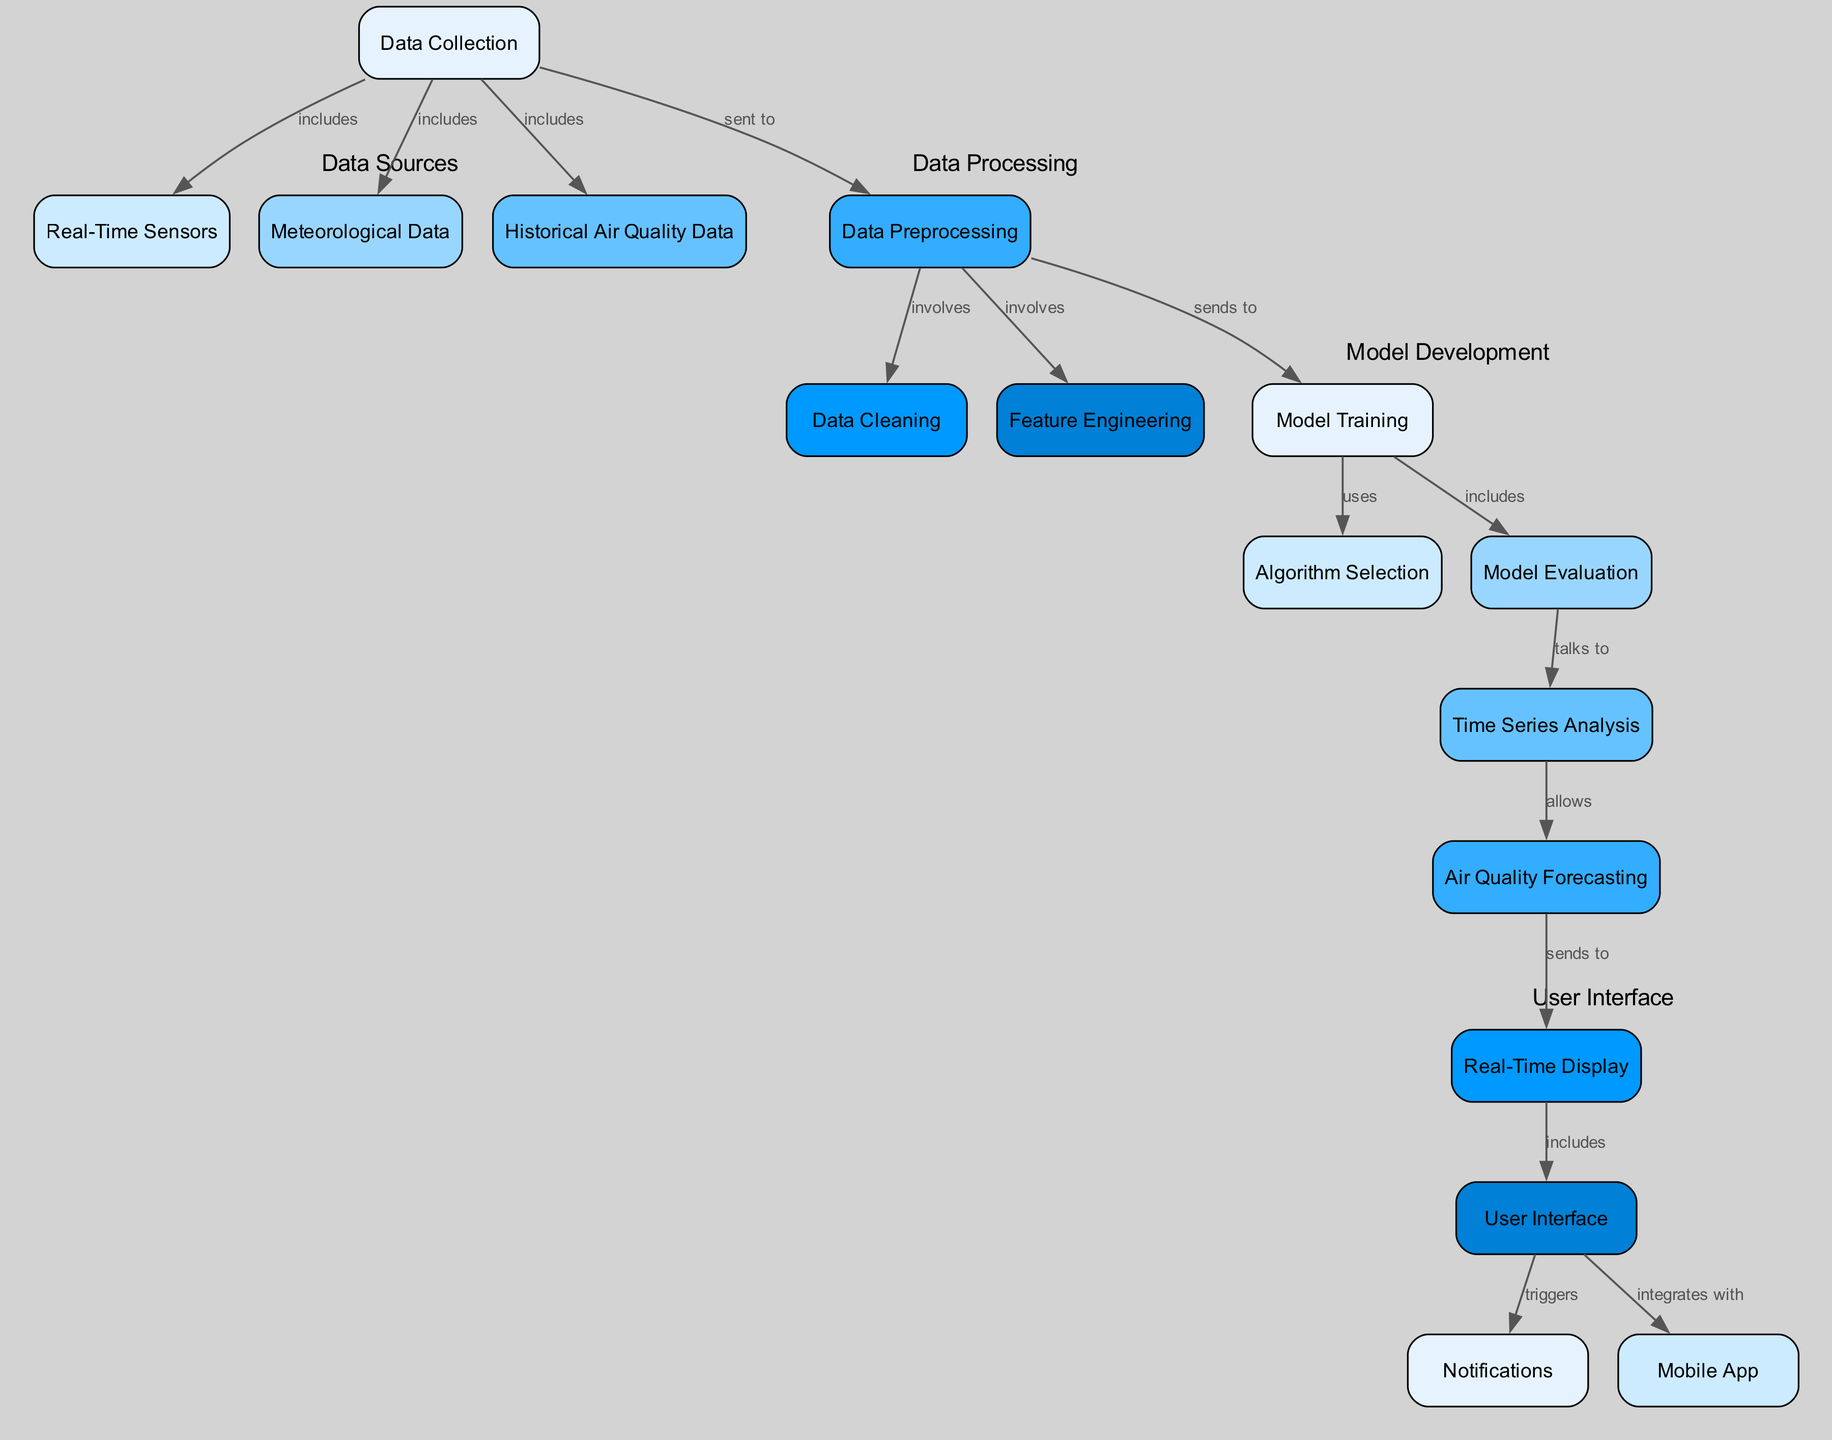What is the first step in the process? The first step in the process is represented by the node "Data Collection," which serves as the starting point for gathering various types of data.
Answer: Data Collection How many nodes are in the diagram? The diagram contains a total of 15 nodes, each representing different components of the air quality monitoring and forecasting system.
Answer: 15 What type of data is included in the Data Collection node? The Data Collection node includes three types of data: Real-Time Sensors, Meteorological Data, and Historical Air Quality Data.
Answer: Real-Time Sensors, Meteorological Data, Historical Air Quality Data What does the Time Series Analysis node allow? The Time Series Analysis node allows the forecasting of air quality based on processed data and established patterns over time, which is essential for predicting air quality levels.
Answer: Forecasting Which component triggers notifications? The User Interface component triggers notifications based on user interactions and alerts derived from the air quality data presented in the application.
Answer: User Interface What is the relationship between Model Training and Algorithm Selection? The relationship is defined by the label "uses," indicating that the Model Training node relies on Algorithm Selection in order to determine which algorithms to apply for training.
Answer: uses How many edges are there in the diagram? The diagram includes a total of 14 edges, which represent the relationships and pathways between the various nodes in the process.
Answer: 14 What is the output of the Forecasting node? The output of the Forecasting node is sent to the Real-Time Display, where users can view the predicted air quality levels in a timely manner.
Answer: Real-Time Display Which node integrates with the Mobile App? The User Interface node integrates with the Mobile App, allowing users to interact with the air quality data and receive notifications directly on their devices.
Answer: User Interface What does the Data Preprocessing node involve? The Data Preprocessing node involves the processes of cleaning and feature engineering, which are crucial for preparing data for model training.
Answer: cleaning, feature engineering 